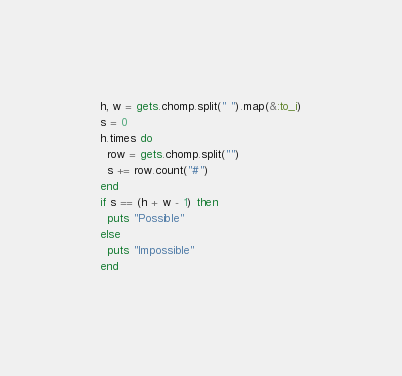<code> <loc_0><loc_0><loc_500><loc_500><_Ruby_>h, w = gets.chomp.split(" ").map(&:to_i)
s = 0
h.times do
  row = gets.chomp.split("")
  s += row.count("#")
end
if s == (h + w - 1) then
  puts "Possible"
else
  puts "Impossible"
end</code> 